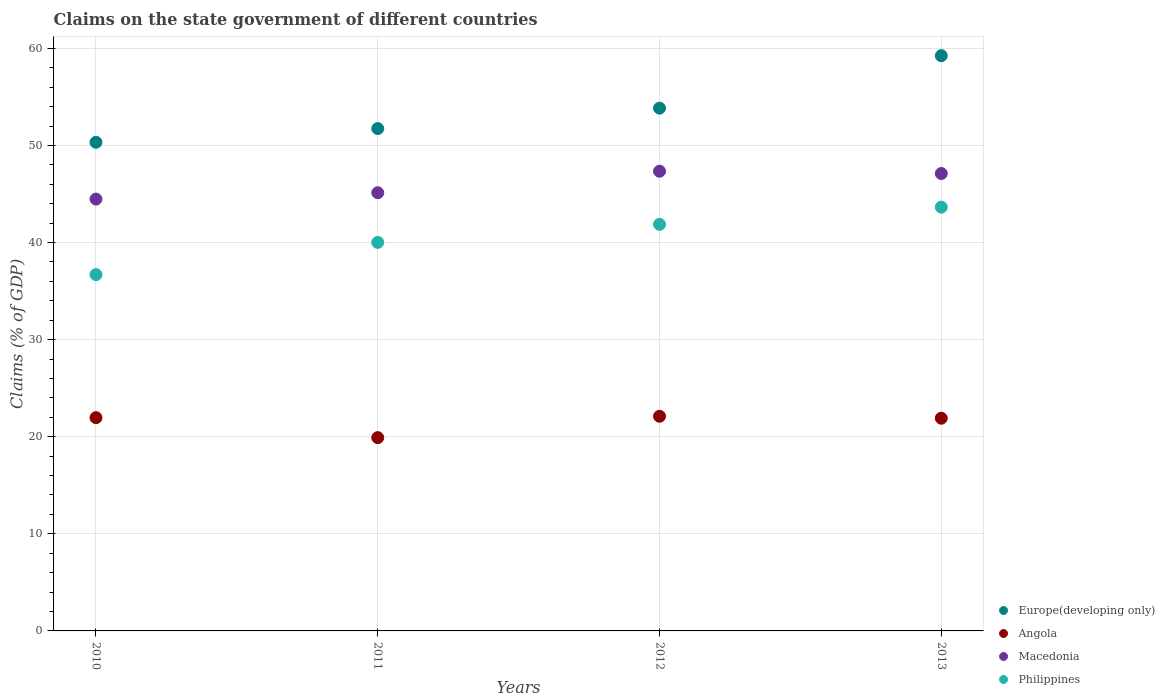How many different coloured dotlines are there?
Offer a very short reply. 4. Is the number of dotlines equal to the number of legend labels?
Your answer should be compact. Yes. What is the percentage of GDP claimed on the state government in Macedonia in 2011?
Your response must be concise. 45.13. Across all years, what is the maximum percentage of GDP claimed on the state government in Philippines?
Give a very brief answer. 43.65. Across all years, what is the minimum percentage of GDP claimed on the state government in Europe(developing only)?
Offer a terse response. 50.33. In which year was the percentage of GDP claimed on the state government in Angola maximum?
Your answer should be compact. 2012. In which year was the percentage of GDP claimed on the state government in Macedonia minimum?
Offer a very short reply. 2010. What is the total percentage of GDP claimed on the state government in Macedonia in the graph?
Offer a very short reply. 184.06. What is the difference between the percentage of GDP claimed on the state government in Europe(developing only) in 2010 and that in 2013?
Give a very brief answer. -8.92. What is the difference between the percentage of GDP claimed on the state government in Europe(developing only) in 2011 and the percentage of GDP claimed on the state government in Macedonia in 2013?
Ensure brevity in your answer.  4.63. What is the average percentage of GDP claimed on the state government in Europe(developing only) per year?
Provide a short and direct response. 53.79. In the year 2011, what is the difference between the percentage of GDP claimed on the state government in Angola and percentage of GDP claimed on the state government in Europe(developing only)?
Your response must be concise. -31.83. What is the ratio of the percentage of GDP claimed on the state government in Macedonia in 2010 to that in 2011?
Make the answer very short. 0.99. Is the difference between the percentage of GDP claimed on the state government in Angola in 2010 and 2013 greater than the difference between the percentage of GDP claimed on the state government in Europe(developing only) in 2010 and 2013?
Ensure brevity in your answer.  Yes. What is the difference between the highest and the second highest percentage of GDP claimed on the state government in Europe(developing only)?
Offer a terse response. 5.41. What is the difference between the highest and the lowest percentage of GDP claimed on the state government in Macedonia?
Provide a short and direct response. 2.87. Is the sum of the percentage of GDP claimed on the state government in Philippines in 2011 and 2012 greater than the maximum percentage of GDP claimed on the state government in Angola across all years?
Offer a very short reply. Yes. Is it the case that in every year, the sum of the percentage of GDP claimed on the state government in Macedonia and percentage of GDP claimed on the state government in Angola  is greater than the sum of percentage of GDP claimed on the state government in Philippines and percentage of GDP claimed on the state government in Europe(developing only)?
Offer a terse response. No. How many years are there in the graph?
Give a very brief answer. 4. What is the difference between two consecutive major ticks on the Y-axis?
Your answer should be very brief. 10. Does the graph contain any zero values?
Make the answer very short. No. Does the graph contain grids?
Offer a terse response. Yes. Where does the legend appear in the graph?
Your answer should be very brief. Bottom right. What is the title of the graph?
Make the answer very short. Claims on the state government of different countries. Does "Guyana" appear as one of the legend labels in the graph?
Your response must be concise. No. What is the label or title of the X-axis?
Your answer should be very brief. Years. What is the label or title of the Y-axis?
Keep it short and to the point. Claims (% of GDP). What is the Claims (% of GDP) in Europe(developing only) in 2010?
Your answer should be very brief. 50.33. What is the Claims (% of GDP) of Angola in 2010?
Make the answer very short. 21.96. What is the Claims (% of GDP) in Macedonia in 2010?
Provide a short and direct response. 44.48. What is the Claims (% of GDP) of Philippines in 2010?
Offer a terse response. 36.7. What is the Claims (% of GDP) in Europe(developing only) in 2011?
Offer a very short reply. 51.74. What is the Claims (% of GDP) of Angola in 2011?
Offer a terse response. 19.91. What is the Claims (% of GDP) in Macedonia in 2011?
Your response must be concise. 45.13. What is the Claims (% of GDP) of Philippines in 2011?
Your response must be concise. 40.02. What is the Claims (% of GDP) of Europe(developing only) in 2012?
Your answer should be very brief. 53.84. What is the Claims (% of GDP) in Angola in 2012?
Ensure brevity in your answer.  22.11. What is the Claims (% of GDP) in Macedonia in 2012?
Your response must be concise. 47.35. What is the Claims (% of GDP) of Philippines in 2012?
Keep it short and to the point. 41.88. What is the Claims (% of GDP) of Europe(developing only) in 2013?
Offer a terse response. 59.25. What is the Claims (% of GDP) in Angola in 2013?
Ensure brevity in your answer.  21.91. What is the Claims (% of GDP) in Macedonia in 2013?
Provide a short and direct response. 47.11. What is the Claims (% of GDP) in Philippines in 2013?
Offer a very short reply. 43.65. Across all years, what is the maximum Claims (% of GDP) of Europe(developing only)?
Offer a very short reply. 59.25. Across all years, what is the maximum Claims (% of GDP) in Angola?
Provide a succinct answer. 22.11. Across all years, what is the maximum Claims (% of GDP) of Macedonia?
Your answer should be very brief. 47.35. Across all years, what is the maximum Claims (% of GDP) in Philippines?
Ensure brevity in your answer.  43.65. Across all years, what is the minimum Claims (% of GDP) in Europe(developing only)?
Your response must be concise. 50.33. Across all years, what is the minimum Claims (% of GDP) of Angola?
Provide a succinct answer. 19.91. Across all years, what is the minimum Claims (% of GDP) in Macedonia?
Offer a very short reply. 44.48. Across all years, what is the minimum Claims (% of GDP) of Philippines?
Your response must be concise. 36.7. What is the total Claims (% of GDP) of Europe(developing only) in the graph?
Give a very brief answer. 215.15. What is the total Claims (% of GDP) of Angola in the graph?
Your response must be concise. 85.89. What is the total Claims (% of GDP) of Macedonia in the graph?
Provide a succinct answer. 184.06. What is the total Claims (% of GDP) in Philippines in the graph?
Offer a terse response. 162.24. What is the difference between the Claims (% of GDP) in Europe(developing only) in 2010 and that in 2011?
Keep it short and to the point. -1.41. What is the difference between the Claims (% of GDP) of Angola in 2010 and that in 2011?
Ensure brevity in your answer.  2.05. What is the difference between the Claims (% of GDP) of Macedonia in 2010 and that in 2011?
Make the answer very short. -0.65. What is the difference between the Claims (% of GDP) of Philippines in 2010 and that in 2011?
Keep it short and to the point. -3.32. What is the difference between the Claims (% of GDP) of Europe(developing only) in 2010 and that in 2012?
Offer a very short reply. -3.51. What is the difference between the Claims (% of GDP) in Angola in 2010 and that in 2012?
Provide a short and direct response. -0.15. What is the difference between the Claims (% of GDP) in Macedonia in 2010 and that in 2012?
Ensure brevity in your answer.  -2.87. What is the difference between the Claims (% of GDP) of Philippines in 2010 and that in 2012?
Offer a terse response. -5.18. What is the difference between the Claims (% of GDP) in Europe(developing only) in 2010 and that in 2013?
Offer a terse response. -8.92. What is the difference between the Claims (% of GDP) of Angola in 2010 and that in 2013?
Give a very brief answer. 0.05. What is the difference between the Claims (% of GDP) in Macedonia in 2010 and that in 2013?
Offer a very short reply. -2.63. What is the difference between the Claims (% of GDP) in Philippines in 2010 and that in 2013?
Make the answer very short. -6.95. What is the difference between the Claims (% of GDP) of Europe(developing only) in 2011 and that in 2012?
Offer a terse response. -2.1. What is the difference between the Claims (% of GDP) in Angola in 2011 and that in 2012?
Give a very brief answer. -2.2. What is the difference between the Claims (% of GDP) of Macedonia in 2011 and that in 2012?
Offer a very short reply. -2.22. What is the difference between the Claims (% of GDP) of Philippines in 2011 and that in 2012?
Offer a very short reply. -1.86. What is the difference between the Claims (% of GDP) of Europe(developing only) in 2011 and that in 2013?
Provide a succinct answer. -7.51. What is the difference between the Claims (% of GDP) in Angola in 2011 and that in 2013?
Offer a very short reply. -2. What is the difference between the Claims (% of GDP) in Macedonia in 2011 and that in 2013?
Your answer should be compact. -1.98. What is the difference between the Claims (% of GDP) in Philippines in 2011 and that in 2013?
Ensure brevity in your answer.  -3.63. What is the difference between the Claims (% of GDP) in Europe(developing only) in 2012 and that in 2013?
Provide a succinct answer. -5.41. What is the difference between the Claims (% of GDP) of Angola in 2012 and that in 2013?
Your response must be concise. 0.2. What is the difference between the Claims (% of GDP) of Macedonia in 2012 and that in 2013?
Offer a very short reply. 0.24. What is the difference between the Claims (% of GDP) in Philippines in 2012 and that in 2013?
Your answer should be compact. -1.77. What is the difference between the Claims (% of GDP) of Europe(developing only) in 2010 and the Claims (% of GDP) of Angola in 2011?
Your answer should be very brief. 30.42. What is the difference between the Claims (% of GDP) of Europe(developing only) in 2010 and the Claims (% of GDP) of Macedonia in 2011?
Make the answer very short. 5.2. What is the difference between the Claims (% of GDP) of Europe(developing only) in 2010 and the Claims (% of GDP) of Philippines in 2011?
Provide a succinct answer. 10.31. What is the difference between the Claims (% of GDP) in Angola in 2010 and the Claims (% of GDP) in Macedonia in 2011?
Offer a terse response. -23.17. What is the difference between the Claims (% of GDP) of Angola in 2010 and the Claims (% of GDP) of Philippines in 2011?
Provide a succinct answer. -18.05. What is the difference between the Claims (% of GDP) in Macedonia in 2010 and the Claims (% of GDP) in Philippines in 2011?
Offer a terse response. 4.46. What is the difference between the Claims (% of GDP) in Europe(developing only) in 2010 and the Claims (% of GDP) in Angola in 2012?
Ensure brevity in your answer.  28.22. What is the difference between the Claims (% of GDP) in Europe(developing only) in 2010 and the Claims (% of GDP) in Macedonia in 2012?
Your answer should be compact. 2.98. What is the difference between the Claims (% of GDP) of Europe(developing only) in 2010 and the Claims (% of GDP) of Philippines in 2012?
Your answer should be compact. 8.45. What is the difference between the Claims (% of GDP) in Angola in 2010 and the Claims (% of GDP) in Macedonia in 2012?
Ensure brevity in your answer.  -25.38. What is the difference between the Claims (% of GDP) in Angola in 2010 and the Claims (% of GDP) in Philippines in 2012?
Your answer should be compact. -19.91. What is the difference between the Claims (% of GDP) in Macedonia in 2010 and the Claims (% of GDP) in Philippines in 2012?
Your answer should be very brief. 2.6. What is the difference between the Claims (% of GDP) of Europe(developing only) in 2010 and the Claims (% of GDP) of Angola in 2013?
Provide a succinct answer. 28.42. What is the difference between the Claims (% of GDP) of Europe(developing only) in 2010 and the Claims (% of GDP) of Macedonia in 2013?
Provide a short and direct response. 3.22. What is the difference between the Claims (% of GDP) of Europe(developing only) in 2010 and the Claims (% of GDP) of Philippines in 2013?
Your response must be concise. 6.68. What is the difference between the Claims (% of GDP) in Angola in 2010 and the Claims (% of GDP) in Macedonia in 2013?
Your answer should be compact. -25.15. What is the difference between the Claims (% of GDP) in Angola in 2010 and the Claims (% of GDP) in Philippines in 2013?
Make the answer very short. -21.68. What is the difference between the Claims (% of GDP) of Macedonia in 2010 and the Claims (% of GDP) of Philippines in 2013?
Your answer should be very brief. 0.83. What is the difference between the Claims (% of GDP) of Europe(developing only) in 2011 and the Claims (% of GDP) of Angola in 2012?
Offer a terse response. 29.63. What is the difference between the Claims (% of GDP) in Europe(developing only) in 2011 and the Claims (% of GDP) in Macedonia in 2012?
Ensure brevity in your answer.  4.39. What is the difference between the Claims (% of GDP) in Europe(developing only) in 2011 and the Claims (% of GDP) in Philippines in 2012?
Your answer should be very brief. 9.86. What is the difference between the Claims (% of GDP) in Angola in 2011 and the Claims (% of GDP) in Macedonia in 2012?
Offer a terse response. -27.44. What is the difference between the Claims (% of GDP) of Angola in 2011 and the Claims (% of GDP) of Philippines in 2012?
Provide a succinct answer. -21.97. What is the difference between the Claims (% of GDP) in Macedonia in 2011 and the Claims (% of GDP) in Philippines in 2012?
Offer a terse response. 3.25. What is the difference between the Claims (% of GDP) of Europe(developing only) in 2011 and the Claims (% of GDP) of Angola in 2013?
Keep it short and to the point. 29.83. What is the difference between the Claims (% of GDP) of Europe(developing only) in 2011 and the Claims (% of GDP) of Macedonia in 2013?
Keep it short and to the point. 4.63. What is the difference between the Claims (% of GDP) of Europe(developing only) in 2011 and the Claims (% of GDP) of Philippines in 2013?
Your answer should be very brief. 8.09. What is the difference between the Claims (% of GDP) in Angola in 2011 and the Claims (% of GDP) in Macedonia in 2013?
Provide a short and direct response. -27.2. What is the difference between the Claims (% of GDP) of Angola in 2011 and the Claims (% of GDP) of Philippines in 2013?
Make the answer very short. -23.74. What is the difference between the Claims (% of GDP) in Macedonia in 2011 and the Claims (% of GDP) in Philippines in 2013?
Keep it short and to the point. 1.48. What is the difference between the Claims (% of GDP) in Europe(developing only) in 2012 and the Claims (% of GDP) in Angola in 2013?
Your response must be concise. 31.93. What is the difference between the Claims (% of GDP) of Europe(developing only) in 2012 and the Claims (% of GDP) of Macedonia in 2013?
Give a very brief answer. 6.73. What is the difference between the Claims (% of GDP) of Europe(developing only) in 2012 and the Claims (% of GDP) of Philippines in 2013?
Your answer should be compact. 10.19. What is the difference between the Claims (% of GDP) of Angola in 2012 and the Claims (% of GDP) of Macedonia in 2013?
Offer a terse response. -25. What is the difference between the Claims (% of GDP) of Angola in 2012 and the Claims (% of GDP) of Philippines in 2013?
Give a very brief answer. -21.54. What is the difference between the Claims (% of GDP) in Macedonia in 2012 and the Claims (% of GDP) in Philippines in 2013?
Provide a succinct answer. 3.7. What is the average Claims (% of GDP) in Europe(developing only) per year?
Ensure brevity in your answer.  53.79. What is the average Claims (% of GDP) of Angola per year?
Make the answer very short. 21.47. What is the average Claims (% of GDP) of Macedonia per year?
Give a very brief answer. 46.02. What is the average Claims (% of GDP) of Philippines per year?
Your response must be concise. 40.56. In the year 2010, what is the difference between the Claims (% of GDP) in Europe(developing only) and Claims (% of GDP) in Angola?
Keep it short and to the point. 28.36. In the year 2010, what is the difference between the Claims (% of GDP) of Europe(developing only) and Claims (% of GDP) of Macedonia?
Offer a very short reply. 5.85. In the year 2010, what is the difference between the Claims (% of GDP) of Europe(developing only) and Claims (% of GDP) of Philippines?
Ensure brevity in your answer.  13.63. In the year 2010, what is the difference between the Claims (% of GDP) in Angola and Claims (% of GDP) in Macedonia?
Provide a short and direct response. -22.51. In the year 2010, what is the difference between the Claims (% of GDP) of Angola and Claims (% of GDP) of Philippines?
Your answer should be very brief. -14.74. In the year 2010, what is the difference between the Claims (% of GDP) in Macedonia and Claims (% of GDP) in Philippines?
Provide a succinct answer. 7.78. In the year 2011, what is the difference between the Claims (% of GDP) in Europe(developing only) and Claims (% of GDP) in Angola?
Your response must be concise. 31.83. In the year 2011, what is the difference between the Claims (% of GDP) of Europe(developing only) and Claims (% of GDP) of Macedonia?
Ensure brevity in your answer.  6.61. In the year 2011, what is the difference between the Claims (% of GDP) in Europe(developing only) and Claims (% of GDP) in Philippines?
Your answer should be very brief. 11.72. In the year 2011, what is the difference between the Claims (% of GDP) in Angola and Claims (% of GDP) in Macedonia?
Keep it short and to the point. -25.22. In the year 2011, what is the difference between the Claims (% of GDP) in Angola and Claims (% of GDP) in Philippines?
Your answer should be compact. -20.11. In the year 2011, what is the difference between the Claims (% of GDP) of Macedonia and Claims (% of GDP) of Philippines?
Ensure brevity in your answer.  5.11. In the year 2012, what is the difference between the Claims (% of GDP) in Europe(developing only) and Claims (% of GDP) in Angola?
Your response must be concise. 31.73. In the year 2012, what is the difference between the Claims (% of GDP) of Europe(developing only) and Claims (% of GDP) of Macedonia?
Provide a short and direct response. 6.49. In the year 2012, what is the difference between the Claims (% of GDP) in Europe(developing only) and Claims (% of GDP) in Philippines?
Your answer should be very brief. 11.97. In the year 2012, what is the difference between the Claims (% of GDP) of Angola and Claims (% of GDP) of Macedonia?
Give a very brief answer. -25.24. In the year 2012, what is the difference between the Claims (% of GDP) of Angola and Claims (% of GDP) of Philippines?
Offer a terse response. -19.77. In the year 2012, what is the difference between the Claims (% of GDP) of Macedonia and Claims (% of GDP) of Philippines?
Provide a short and direct response. 5.47. In the year 2013, what is the difference between the Claims (% of GDP) of Europe(developing only) and Claims (% of GDP) of Angola?
Provide a succinct answer. 37.34. In the year 2013, what is the difference between the Claims (% of GDP) in Europe(developing only) and Claims (% of GDP) in Macedonia?
Make the answer very short. 12.14. In the year 2013, what is the difference between the Claims (% of GDP) in Europe(developing only) and Claims (% of GDP) in Philippines?
Your response must be concise. 15.6. In the year 2013, what is the difference between the Claims (% of GDP) of Angola and Claims (% of GDP) of Macedonia?
Keep it short and to the point. -25.2. In the year 2013, what is the difference between the Claims (% of GDP) of Angola and Claims (% of GDP) of Philippines?
Your response must be concise. -21.74. In the year 2013, what is the difference between the Claims (% of GDP) of Macedonia and Claims (% of GDP) of Philippines?
Offer a very short reply. 3.46. What is the ratio of the Claims (% of GDP) of Europe(developing only) in 2010 to that in 2011?
Keep it short and to the point. 0.97. What is the ratio of the Claims (% of GDP) of Angola in 2010 to that in 2011?
Your response must be concise. 1.1. What is the ratio of the Claims (% of GDP) of Macedonia in 2010 to that in 2011?
Your answer should be compact. 0.99. What is the ratio of the Claims (% of GDP) in Philippines in 2010 to that in 2011?
Offer a very short reply. 0.92. What is the ratio of the Claims (% of GDP) in Europe(developing only) in 2010 to that in 2012?
Give a very brief answer. 0.93. What is the ratio of the Claims (% of GDP) of Angola in 2010 to that in 2012?
Provide a short and direct response. 0.99. What is the ratio of the Claims (% of GDP) in Macedonia in 2010 to that in 2012?
Make the answer very short. 0.94. What is the ratio of the Claims (% of GDP) of Philippines in 2010 to that in 2012?
Your answer should be very brief. 0.88. What is the ratio of the Claims (% of GDP) in Europe(developing only) in 2010 to that in 2013?
Your answer should be compact. 0.85. What is the ratio of the Claims (% of GDP) in Macedonia in 2010 to that in 2013?
Your response must be concise. 0.94. What is the ratio of the Claims (% of GDP) of Philippines in 2010 to that in 2013?
Your response must be concise. 0.84. What is the ratio of the Claims (% of GDP) in Europe(developing only) in 2011 to that in 2012?
Make the answer very short. 0.96. What is the ratio of the Claims (% of GDP) in Angola in 2011 to that in 2012?
Your answer should be very brief. 0.9. What is the ratio of the Claims (% of GDP) of Macedonia in 2011 to that in 2012?
Your answer should be compact. 0.95. What is the ratio of the Claims (% of GDP) of Philippines in 2011 to that in 2012?
Provide a short and direct response. 0.96. What is the ratio of the Claims (% of GDP) of Europe(developing only) in 2011 to that in 2013?
Your answer should be compact. 0.87. What is the ratio of the Claims (% of GDP) of Angola in 2011 to that in 2013?
Your response must be concise. 0.91. What is the ratio of the Claims (% of GDP) of Macedonia in 2011 to that in 2013?
Keep it short and to the point. 0.96. What is the ratio of the Claims (% of GDP) of Philippines in 2011 to that in 2013?
Ensure brevity in your answer.  0.92. What is the ratio of the Claims (% of GDP) in Europe(developing only) in 2012 to that in 2013?
Offer a terse response. 0.91. What is the ratio of the Claims (% of GDP) of Angola in 2012 to that in 2013?
Ensure brevity in your answer.  1.01. What is the ratio of the Claims (% of GDP) in Philippines in 2012 to that in 2013?
Your answer should be compact. 0.96. What is the difference between the highest and the second highest Claims (% of GDP) of Europe(developing only)?
Your response must be concise. 5.41. What is the difference between the highest and the second highest Claims (% of GDP) of Angola?
Make the answer very short. 0.15. What is the difference between the highest and the second highest Claims (% of GDP) of Macedonia?
Your answer should be very brief. 0.24. What is the difference between the highest and the second highest Claims (% of GDP) of Philippines?
Keep it short and to the point. 1.77. What is the difference between the highest and the lowest Claims (% of GDP) of Europe(developing only)?
Keep it short and to the point. 8.92. What is the difference between the highest and the lowest Claims (% of GDP) of Angola?
Offer a terse response. 2.2. What is the difference between the highest and the lowest Claims (% of GDP) in Macedonia?
Ensure brevity in your answer.  2.87. What is the difference between the highest and the lowest Claims (% of GDP) of Philippines?
Ensure brevity in your answer.  6.95. 